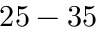<formula> <loc_0><loc_0><loc_500><loc_500>2 5 - 3 5 \</formula> 